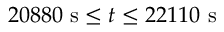<formula> <loc_0><loc_0><loc_500><loc_500>2 0 8 8 0 \ s \leq t \leq 2 2 1 1 0 \ s</formula> 